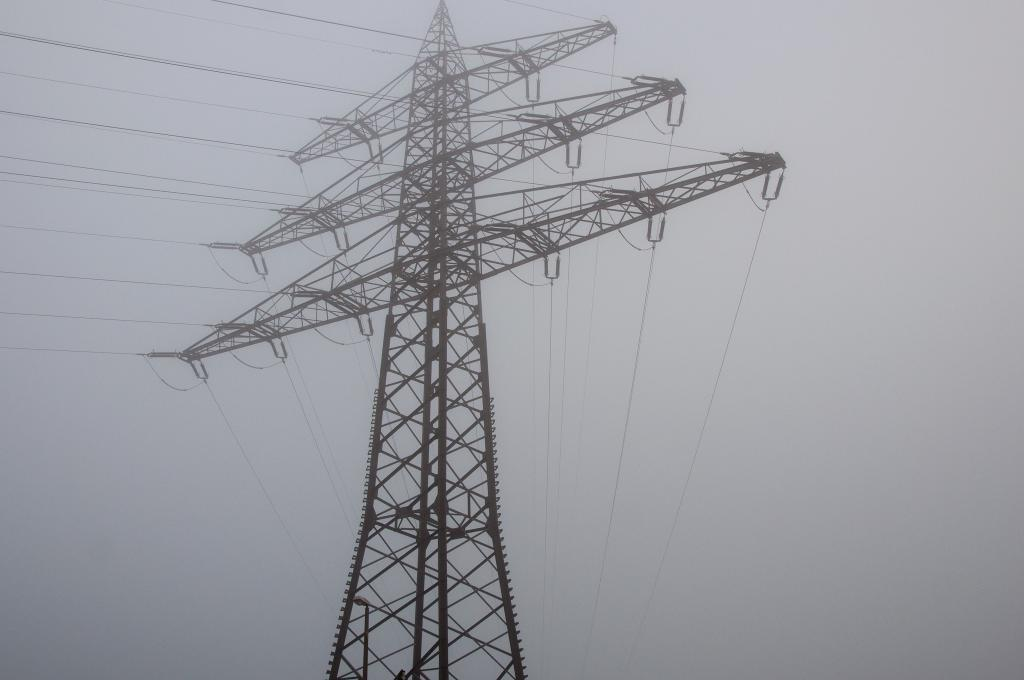What type of structure is present in the image? There is an electric tower in the image. What is connected to the electric tower? There are electric wires in the image. What can be seen in the background of the image? The sky is visible in the image. How many horses are visible in the image? There are no horses present in the image. What type of beam is supporting the electric tower in the image? The image does not provide information about the type of beam supporting the electric tower. 